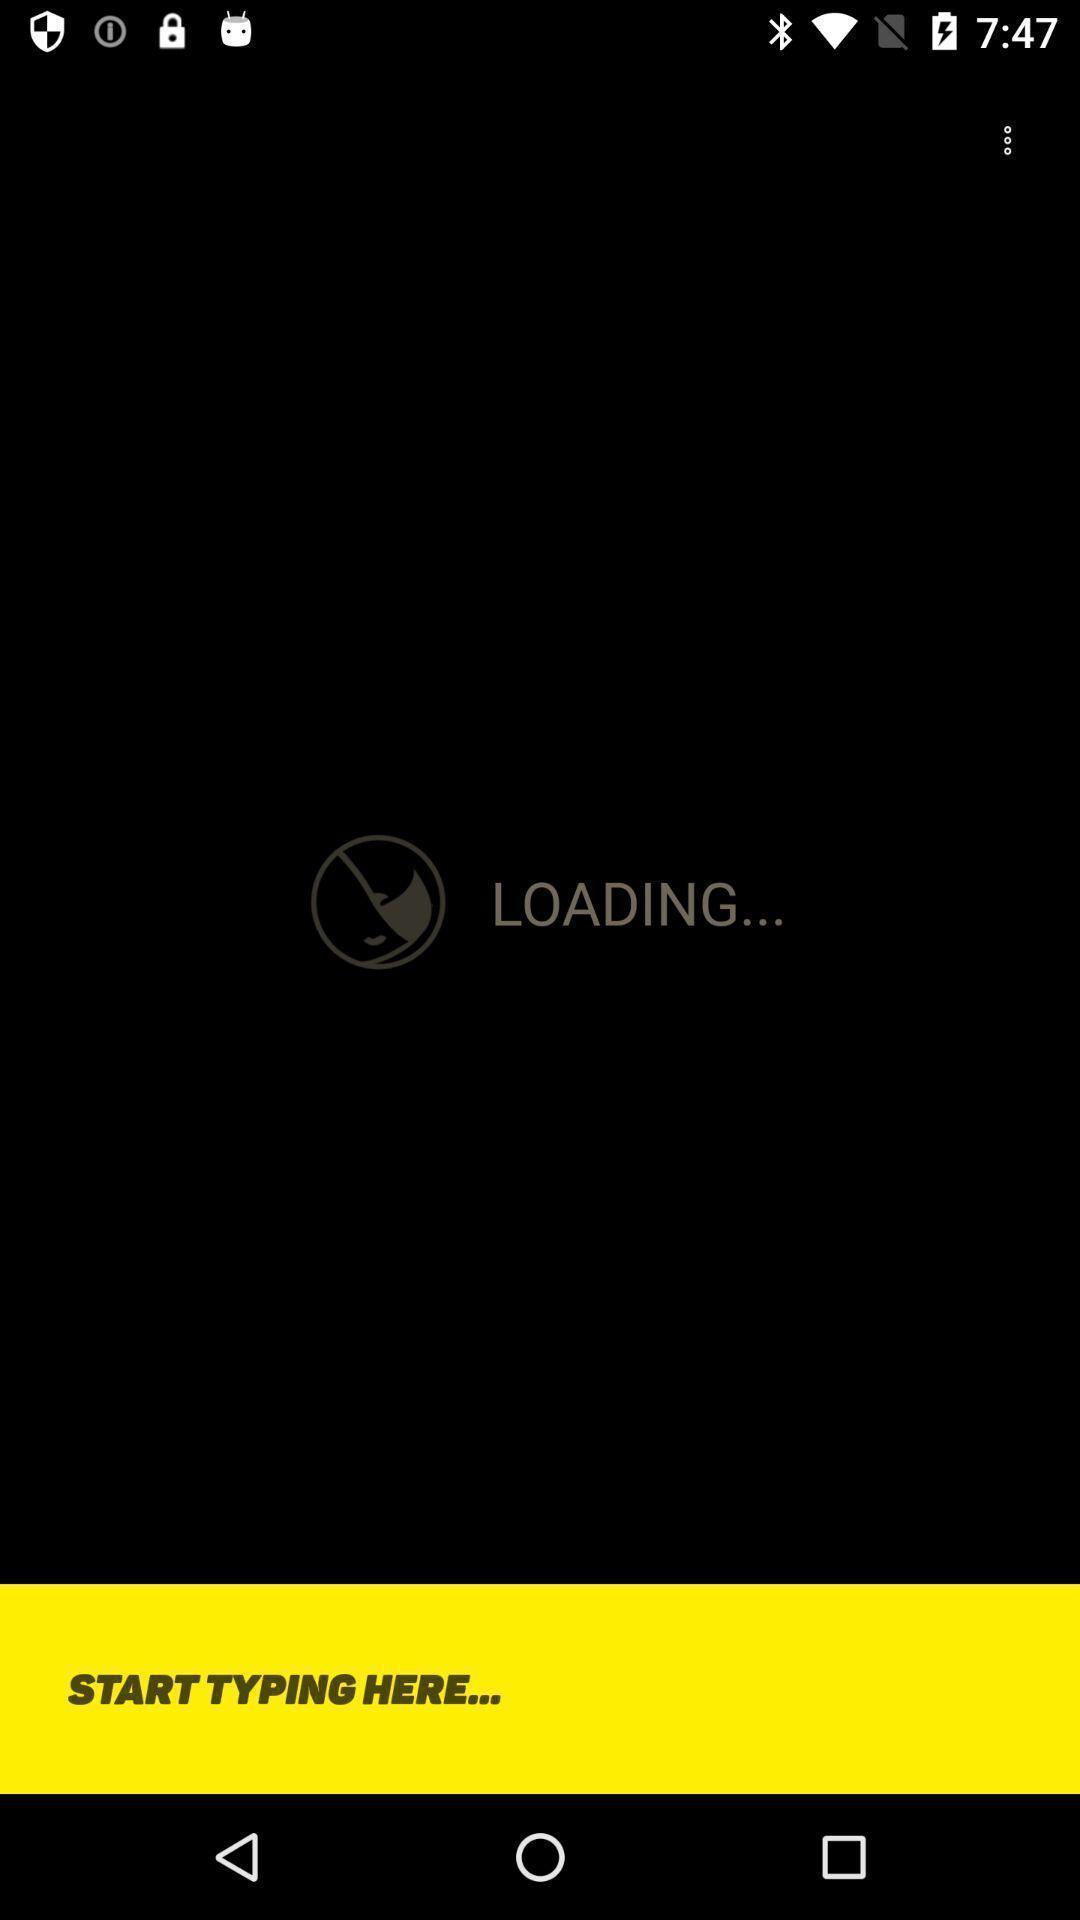Provide a textual representation of this image. Page is showing a typing bar. 